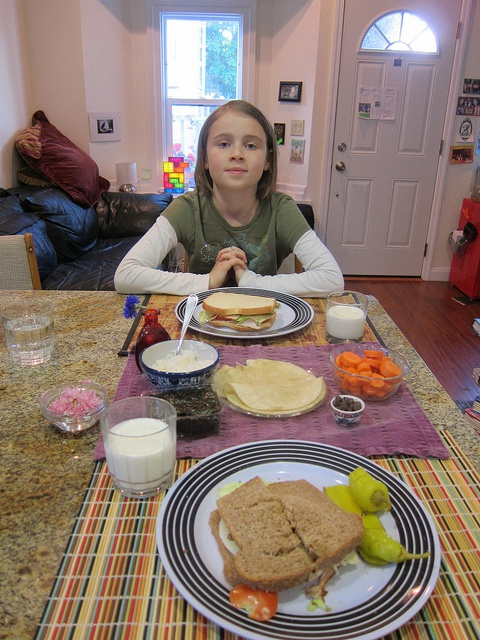Describe the objects in this image and their specific colors. I can see dining table in darkgray, tan, and gray tones, people in darkgray, gray, and black tones, sandwich in darkgray, tan, gray, and brown tones, couch in darkgray, black, gray, and darkblue tones, and cup in darkgray, lightgray, and gray tones in this image. 